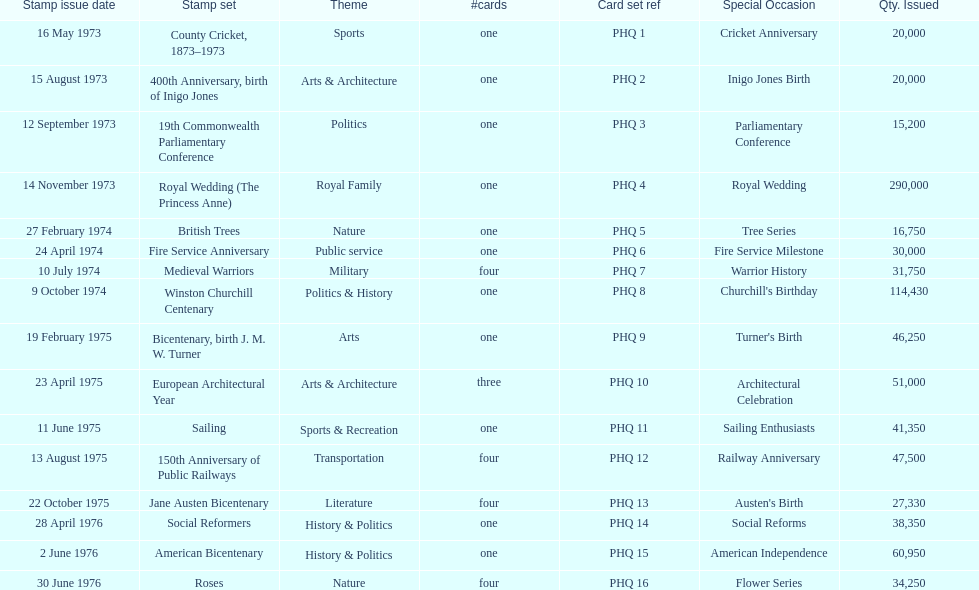Which stamp set had only three cards in the set? European Architectural Year. 